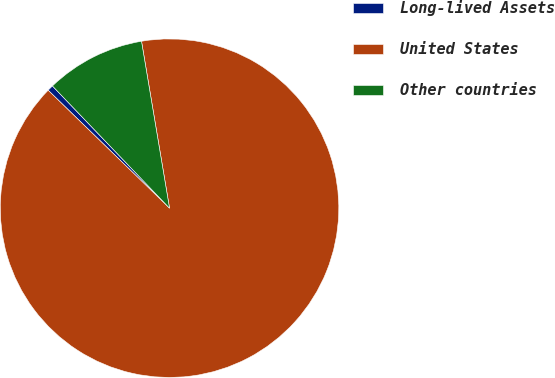Convert chart to OTSL. <chart><loc_0><loc_0><loc_500><loc_500><pie_chart><fcel>Long-lived Assets<fcel>United States<fcel>Other countries<nl><fcel>0.57%<fcel>89.92%<fcel>9.51%<nl></chart> 